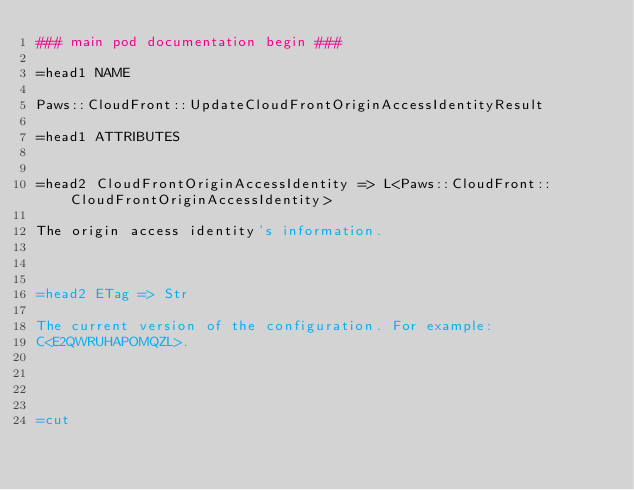Convert code to text. <code><loc_0><loc_0><loc_500><loc_500><_Perl_>### main pod documentation begin ###

=head1 NAME

Paws::CloudFront::UpdateCloudFrontOriginAccessIdentityResult

=head1 ATTRIBUTES


=head2 CloudFrontOriginAccessIdentity => L<Paws::CloudFront::CloudFrontOriginAccessIdentity>

The origin access identity's information.



=head2 ETag => Str

The current version of the configuration. For example:
C<E2QWRUHAPOMQZL>.




=cut

</code> 